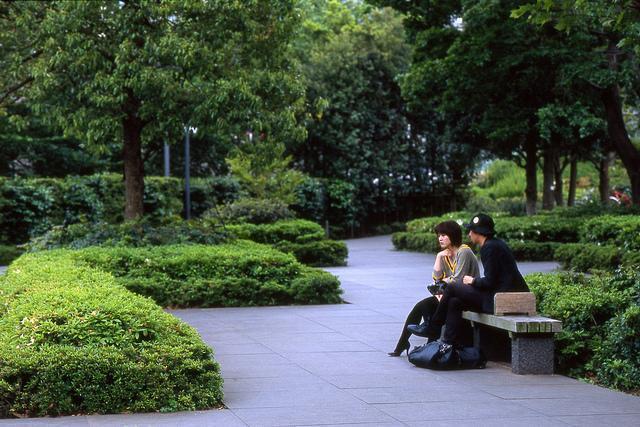How many people are sitting on the bench in the middle of the park?
Answer the question by selecting the correct answer among the 4 following choices and explain your choice with a short sentence. The answer should be formatted with the following format: `Answer: choice
Rationale: rationale.`
Options: Two, four, five, three. Answer: two.
Rationale: There are a couple of people on the bench. 